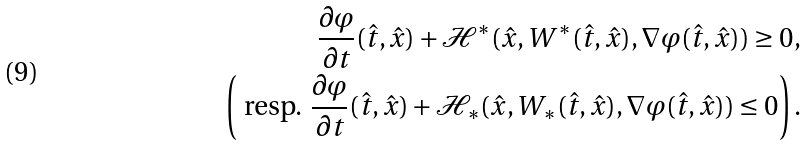<formula> <loc_0><loc_0><loc_500><loc_500>\frac { \partial \varphi } { \partial t } ( \hat { t } , \hat { x } ) + \mathcal { H } ^ { \ast } ( \hat { x } , W ^ { \ast } ( \hat { t } , \hat { x } ) , \nabla \varphi ( \hat { t } , \hat { x } ) ) \geq 0 , \\ \left ( \text { resp. } \frac { \partial \varphi } { \partial t } ( \hat { t } , \hat { x } ) + \mathcal { H } _ { \ast } ( \hat { x } , W _ { \ast } ( \hat { t } , \hat { x } ) , \nabla \varphi ( \hat { t } , \hat { x } ) ) \leq 0 \right ) .</formula> 